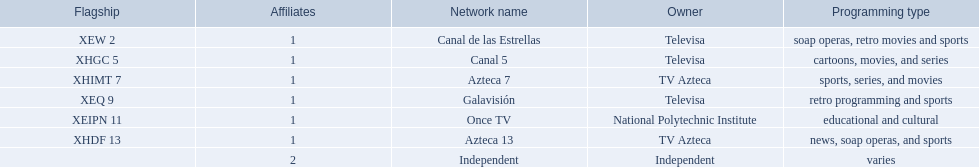What station shows cartoons? Canal 5. What station shows soap operas? Canal de las Estrellas. What station shows sports? Azteca 7. 